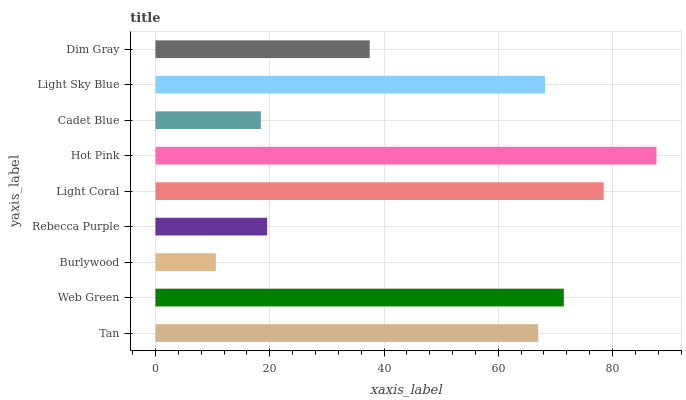Is Burlywood the minimum?
Answer yes or no. Yes. Is Hot Pink the maximum?
Answer yes or no. Yes. Is Web Green the minimum?
Answer yes or no. No. Is Web Green the maximum?
Answer yes or no. No. Is Web Green greater than Tan?
Answer yes or no. Yes. Is Tan less than Web Green?
Answer yes or no. Yes. Is Tan greater than Web Green?
Answer yes or no. No. Is Web Green less than Tan?
Answer yes or no. No. Is Tan the high median?
Answer yes or no. Yes. Is Tan the low median?
Answer yes or no. Yes. Is Hot Pink the high median?
Answer yes or no. No. Is Web Green the low median?
Answer yes or no. No. 